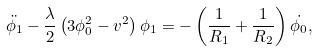Convert formula to latex. <formula><loc_0><loc_0><loc_500><loc_500>\ddot { \phi _ { 1 } } - \frac { \lambda } { 2 } \left ( 3 \phi _ { 0 } ^ { 2 } - v ^ { 2 } \right ) \phi _ { 1 } = - \left ( \frac { 1 } { R _ { 1 } } + \frac { 1 } { R _ { 2 } } \right ) \dot { \phi _ { 0 } } ,</formula> 